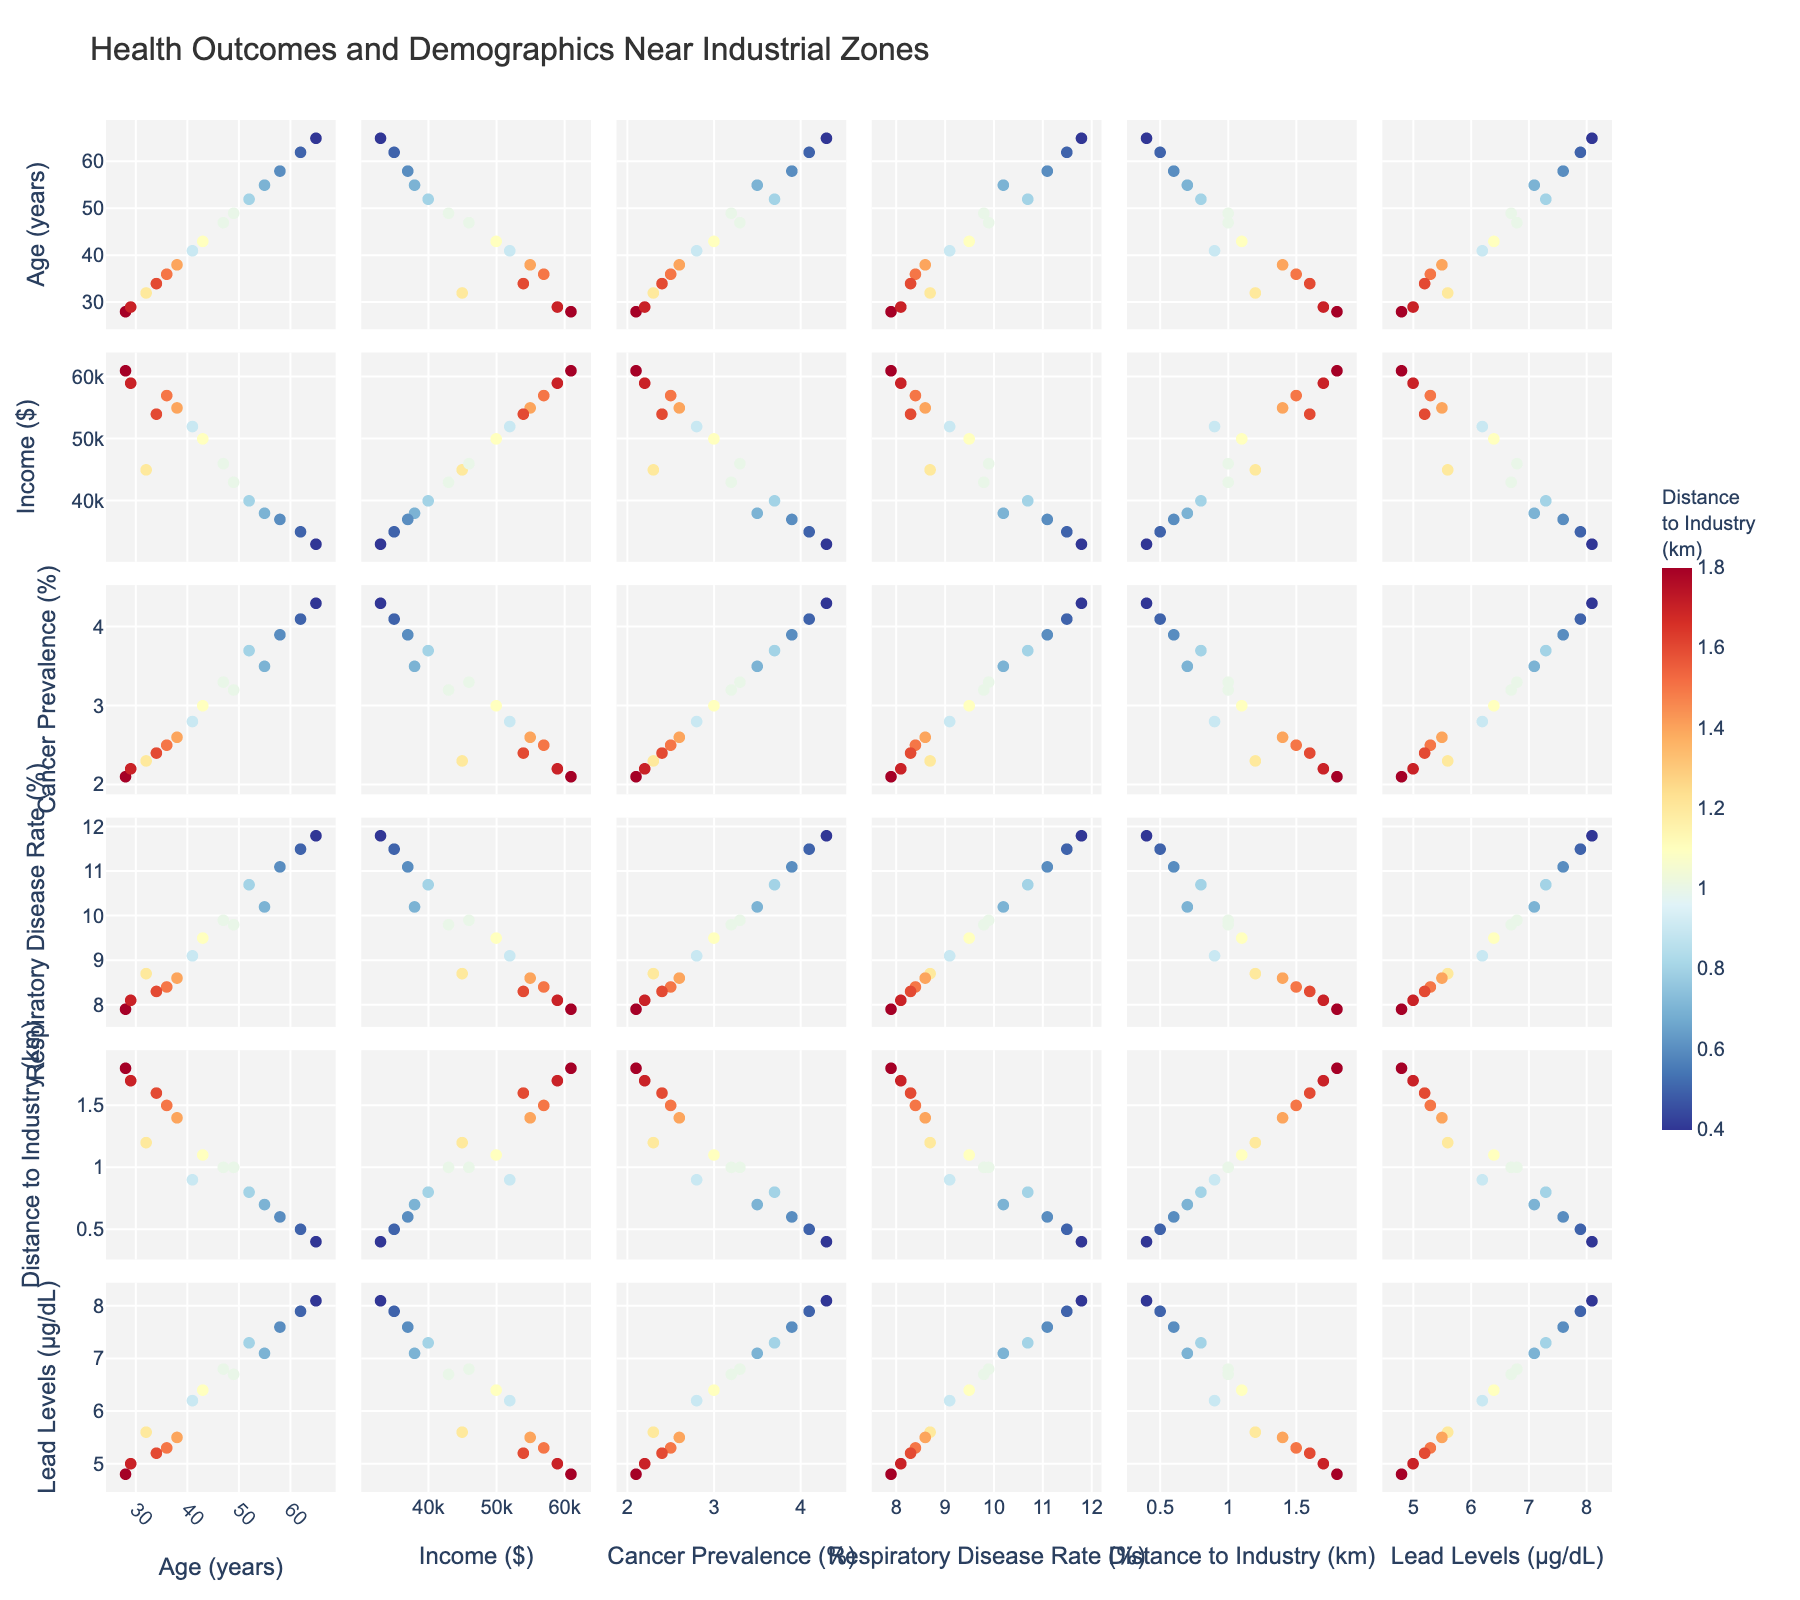What is the title of the figure? The title is usually located at the top center of the figure. It gives an overview of what the plot represents.
Answer: Health Outcomes and Demographics Near Industrial Zones Which color scale is used to represent the "Distance to Industry"? The color scale can be identified by looking at the color bar and its title next to it.
Answer: RdYlBu_r What is the age range of the individuals in this figure? To find the age range, you need to look at the scatter plots involving the 'Age' dimension and note the minimum and maximum values. The minimum age appears around 28 and the maximum around 65.
Answer: 28 to 65 years How does "Income" correlate with "Cancer Prevalence"? Find the scatter plot matrix cell that correlates 'Income' with 'Cancer Prevalence'. Observe for any trend, such as whether higher incomes tend to have higher or lower prevalences. Typically, the plot shows points distributed, but usually, you'd see if there is a noticeable trend (positive, negative, or none).
Answer: No clear trend Do higher lead levels tend to be associated with greater cancer prevalence? In the scatter plot matrix, locate the plot correlating 'Lead Levels' with 'Cancer Prevalence'. Observe if there is any noticeable trend (increasing or decreasing). If points trend upwards, higher lead levels are associated with higher cancer prevalence.
Answer: Yes, there is an increasing trend Which variable has a higher variance: "Income" or "Lead Levels"? To compare variances, you can visually inspect the spread of data points in the scatter plots involving 'Income' versus 'Lead Levels'. Points with a wider spread indicate higher variance. 'Income' points appear more spread out.
Answer: Income Do communities closer to industrial zones have higher rates of respiratory diseases? Look at the plot of 'DistanceToIndustry' versus 'RespiratoryDiseaseRate'. Observe if there is a negative correlation, indicating that as the distance decreases (closer to industry), respiratory disease rates increase.
Answer: Yes, there is a negative correlation Which demographic factor seems to have no clear correlation with "Cancer Prevalence"? Visually inspect plots linking 'CancerPrevalence' to each demographic factor (Age, Income). Identify which factor does not show a clear trend. 'Income' and 'Age' scatter plots for 'CancerPrevalence' appear fairly random without a clear pattern.
Answer: Age and Income What is the relationship between "Age" and "Income"? Find the scatter plot matrix row or column comparing 'Age' to 'Income'. Observe if there's any pattern such as older age corresponding to higher income, or vice versa. The plot suggests no clear correlation.
Answer: No clear correlation 